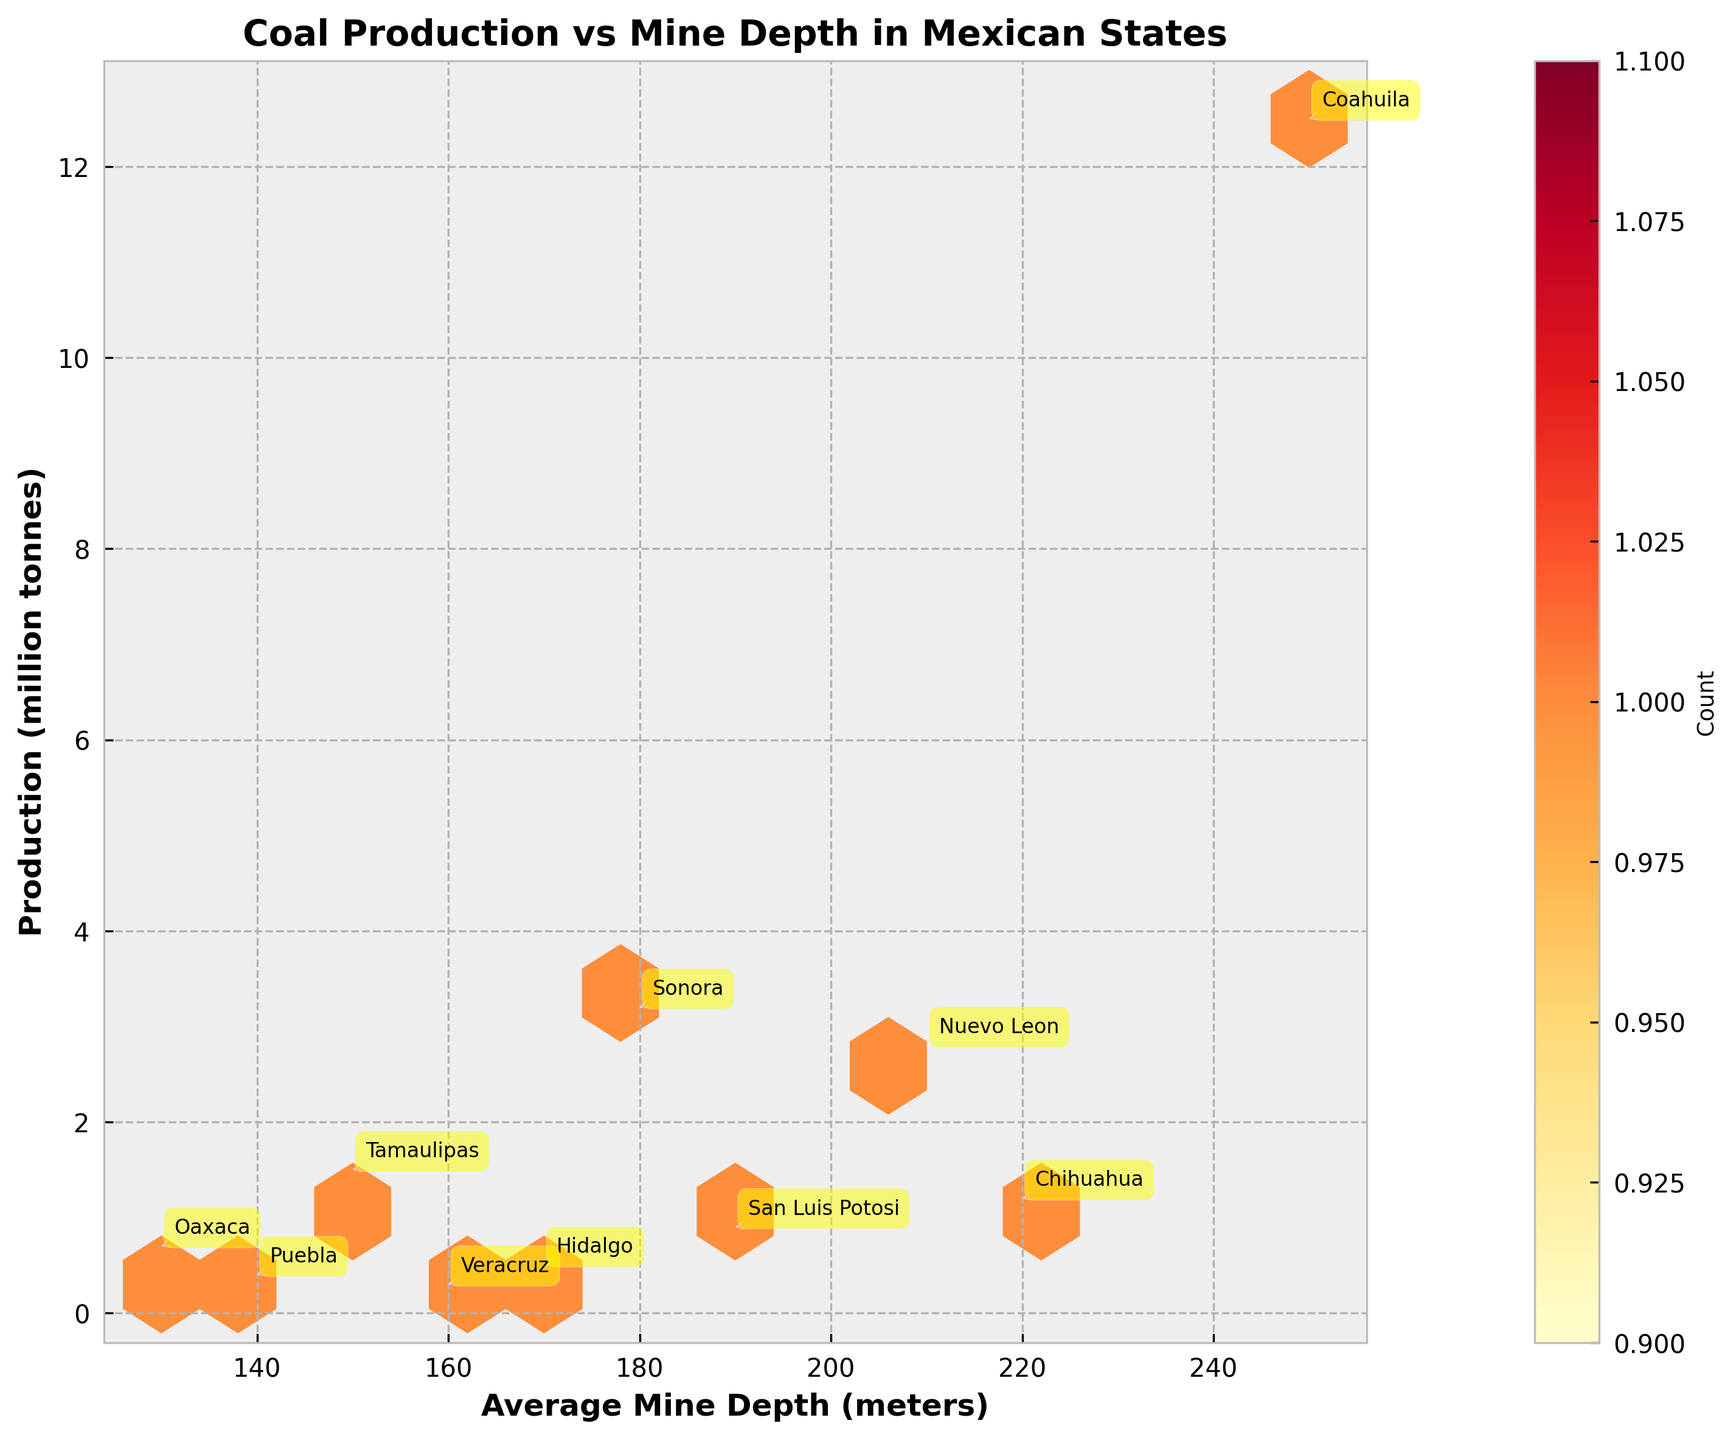What does the title of the plot indicate? The title of the plot, "Coal Production vs Mine Depth in Mexican States," indicates that the figure plots the relationship between the average mine depth and the coal production in different Mexican states.
Answer: Coal Production vs Mine Depth in Mexican States Which state has the highest coal production and what is its average mine depth? The data points are labeled with state names. The state with the highest label is Coahuila at a production value of 12.5 million tonnes and an average mine depth of 250 meters.
Answer: Coahuila; 250 meters How many data points (states) are represented in the plot? Each state's data point is labeled, and counting these labels will give the total number of data points. There are 10 states represented in the plot.
Answer: 10 states Which state has the shallowest average mine depth, and what is its coal production? By looking at the x-axis for the smallest value and checking the labeled states, Oaxaca has the shallowest mine depth at 130 meters with a production value of 0.7 million tonnes.
Answer: Oaxaca; 0.7 million tonnes What is the relationship between mine depth and coal production for the states with the top two productions? The two highest production values are for Coahuila with 12.5 million tonnes and Sonora with 3.2 million tonnes. Coahuila has a deeper mine depth (250m) compared to Sonora (180m).
Answer: Deeper mine depth corresponds to higher production Identify the range of average mine depths in the plot. The range is determined by identifying the smallest and largest x-axis values from the plot labels. The smallest depth is 130 meters (Oaxaca) and the largest is 250 meters (Coahuila).
Answer: 130 meters to 250 meters Is there any state with a similar production value but different mine depths? Comparing production values across the plot shows that Nuevo Leon and Tamaulipas have close production values (2.8 and 1.5 million tonnes respectively) but different mine depths (210 and 150 meters respectively).
Answer: Nuevo Leon and Tamaulipas How are the colors used in the hexbin plot, and what do they represent? Different shades of yellow and red indicate the count of data points in each hexbin. Darker colors suggest higher counts of clustered data points.
Answer: Colors represent count densities Is there a correlation between higher average mine depths and higher coal production? Analyzing the trend in the plot, states with higher production generally seem to have higher average mine depths, indicating a positive correlation.
Answer: Yes, positive correlation What's the label on the color bar, and why is it important? The label on the color bar is "Count," which indicates the number of data points within each hexagon. This helps in understanding the density of data points in the hexbin plot.
Answer: Count 